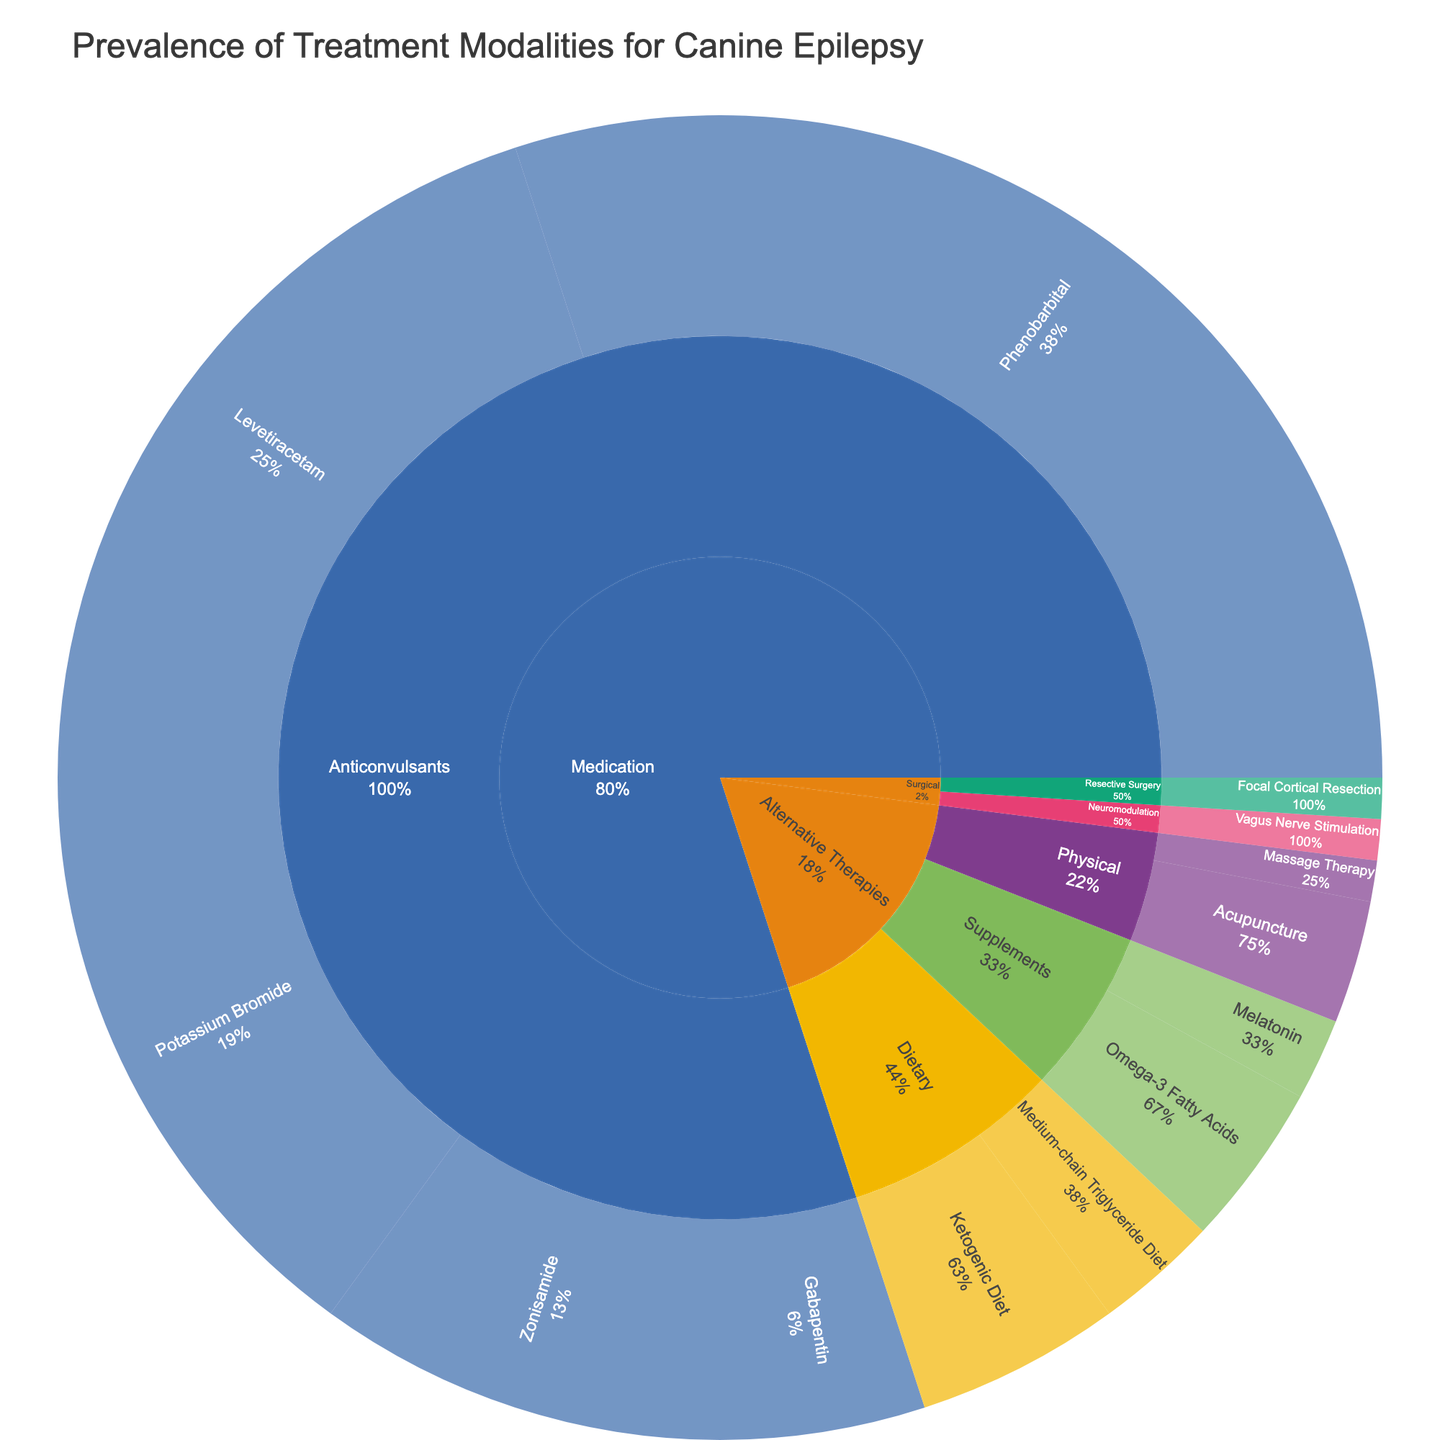What treatment modality is most prevalent for canine epilepsy according to the figure? The largest section of the sunburst plot represents the medication type 'Phenobarbital', indicating it is the most prevalent treatment modality.
Answer: Phenobarbital What is the total percentage of alternative therapies used for treating canine epilepsy? Sum the percentages of all specific treatments under 'Alternative Therapies': (Ketogenic Diet 5 + Medium-chain Triglyceride Diet 3 + Omega-3 Fatty Acids 4 + Melatonin 2 + Acupuncture 3 + Massage Therapy 1) = 18%
Answer: 18% Which specific treatment in the 'Anticonvulsants' category has the second-highest prevalence? Referring to the sunburst plot, 'Levetiracetam' holds the second-largest slice in the 'Anticonvulsants' category after 'Phenobarbital'.
Answer: Levetiracetam How does the prevalence of 'Zonisamide' compare to 'Potassium Bromide'? The plot shows that 'Potassium Bromide' has a larger section (15%) compared to 'Zonisamide' (10%), indicating 'Potassium Bromide' is more prevalent.
Answer: Potassium Bromide is more prevalent What's the percentage difference between the most and least prevalent treatments in the 'Anticonvulsants' category? Difference between 'Phenobarbital' (most prevalent at 30%) and 'Gabapentin' (least prevalent at 5%) is (30 - 5) = 25%.
Answer: 25% What is the combined prevalence of 'Physical' alternative therapies? Sum the percentages of 'Acupuncture' (3%) and 'Massage Therapy' (1%) under the 'Physical' category: 3 + 1 = 4%.
Answer: 4% What category has the smallest representation in the figure? The sunburst plot shows that the 'Surgical' category has the smallest representation, as both treatments ('Focal Cortical Resection' and 'Vagus Nerve Stimulation') have 1% each.
Answer: Surgical How many specific treatments are included in the 'Anticonvulsants' category? By counting the segments under 'Anticonvulsants' in the sunburst plot, you can see there are five specific treatments listed: 'Phenobarbital', 'Potassium Bromide', 'Levetiracetam', 'Zonisamide', and 'Gabapentin'.
Answer: 5 What is the average prevalence percentage of the dietary alternative therapies? Sum the percentages of 'Ketogenic Diet' (5%) and 'Medium-chain Triglyceride Diet' (3%) and divide by the number of treatments: (5 + 3) / 2 = 4%.
Answer: 4% Which treatment category encompasses both dietary changes and physical interventions? 'Alternative Therapies' is the treatment category that includes 'Dietary' (Ketogenic Diet, Medium-chain Triglyceride Diet) and 'Physical' (Acupuncture, Massage Therapy) subcategories.
Answer: Alternative Therapies 